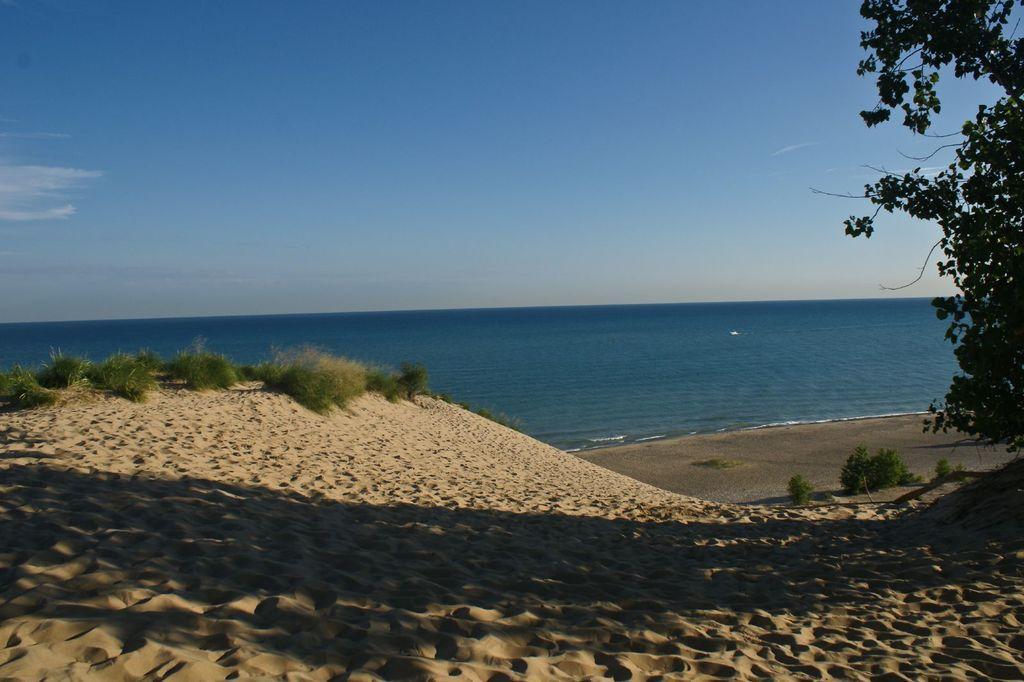How would you summarize this image in a sentence or two? There is grass on the sand surface of a ground. On the right side, there is a tree and there are plants. In the background, there is an ocean and there are clouds in the blue sky. 